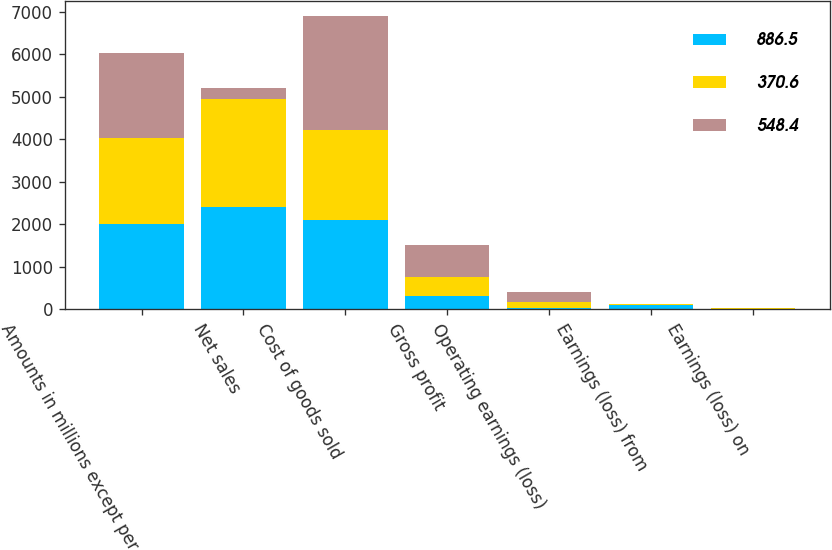Convert chart. <chart><loc_0><loc_0><loc_500><loc_500><stacked_bar_chart><ecel><fcel>Amounts in millions except per<fcel>Net sales<fcel>Cost of goods sold<fcel>Gross profit<fcel>Operating earnings (loss)<fcel>Earnings (loss) from<fcel>Earnings (loss) on<nl><fcel>886.5<fcel>2010<fcel>2405.9<fcel>2105.2<fcel>300.7<fcel>14.5<fcel>102.5<fcel>6<nl><fcel>370.6<fcel>2009<fcel>2543.7<fcel>2097.7<fcel>446<fcel>148.5<fcel>18.6<fcel>11.7<nl><fcel>548.4<fcel>2008<fcel>249.1<fcel>2703.4<fcel>749.7<fcel>249.1<fcel>3.4<fcel>2.5<nl></chart> 